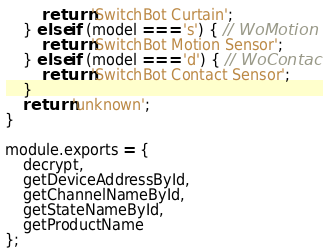<code> <loc_0><loc_0><loc_500><loc_500><_JavaScript_>        return 'SwitchBot Curtain';
    } else if (model === 's') { // WoMotion
        return 'SwitchBot Motion Sensor';
    } else if (model === 'd') { // WoContact
        return 'SwitchBot Contact Sensor';
    }
    return 'unknown';
}

module.exports = {
    decrypt,
    getDeviceAddressById,
    getChannelNameById,
    getStateNameById,
    getProductName
};
</code> 